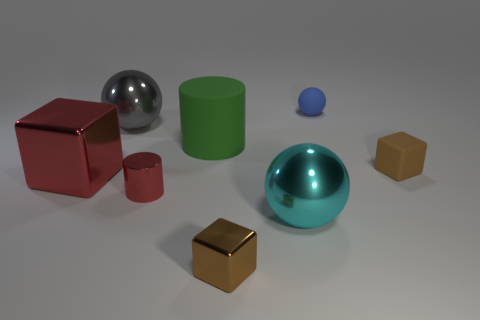How many gray shiny spheres have the same size as the rubber cube?
Keep it short and to the point. 0. The metal block behind the brown shiny cube is what color?
Provide a succinct answer. Red. What number of other things are there of the same size as the gray metal ball?
Your answer should be compact. 3. There is a shiny object that is both in front of the big metallic block and on the left side of the big green matte cylinder; how big is it?
Give a very brief answer. Small. Is the color of the big cylinder the same as the small matte object that is behind the large green thing?
Give a very brief answer. No. Are there any other cyan things that have the same shape as the large rubber object?
Give a very brief answer. No. What number of things are either spheres or objects that are behind the small brown rubber object?
Ensure brevity in your answer.  4. What number of other things are the same material as the gray ball?
Keep it short and to the point. 4. What number of things are cubes or big cyan rubber cylinders?
Provide a succinct answer. 3. Are there more small blocks that are left of the big red shiny thing than small rubber blocks behind the green matte cylinder?
Your answer should be compact. No. 